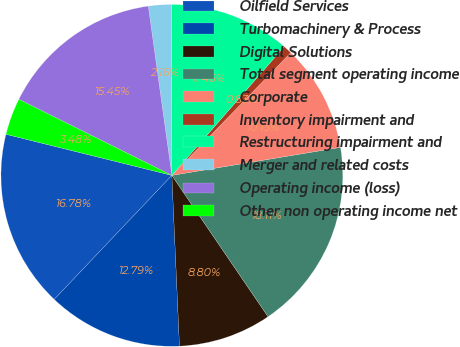Convert chart. <chart><loc_0><loc_0><loc_500><loc_500><pie_chart><fcel>Oilfield Services<fcel>Turbomachinery & Process<fcel>Digital Solutions<fcel>Total segment operating income<fcel>Corporate<fcel>Inventory impairment and<fcel>Restructuring impairment and<fcel>Merger and related costs<fcel>Operating income (loss)<fcel>Other non operating income net<nl><fcel>16.78%<fcel>12.79%<fcel>8.8%<fcel>18.11%<fcel>10.13%<fcel>0.83%<fcel>11.46%<fcel>2.16%<fcel>15.45%<fcel>3.48%<nl></chart> 